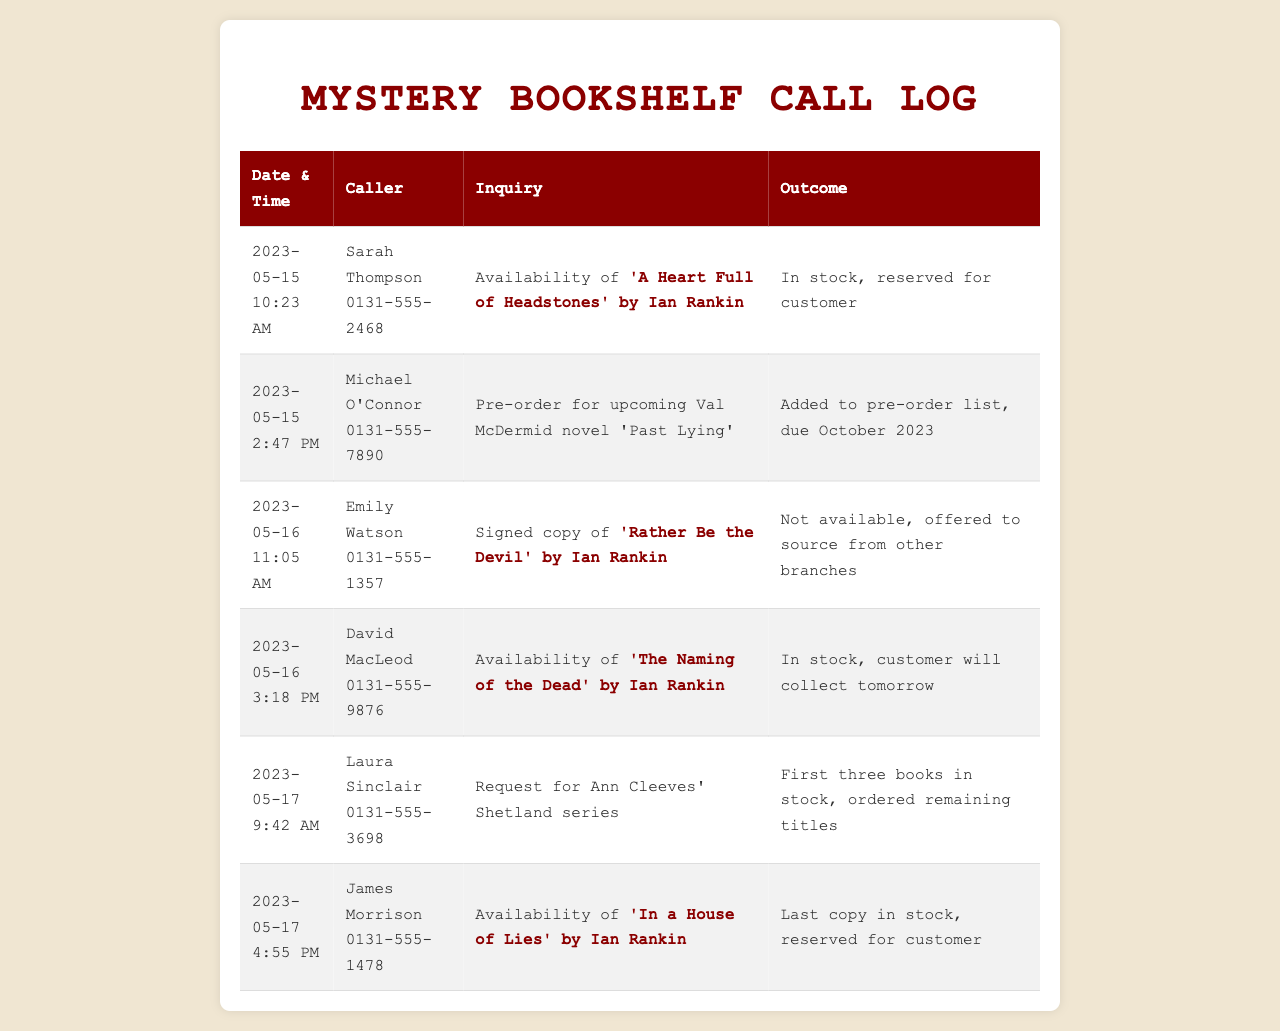what was the date and time of Sarah Thompson's call? Sarah Thompson's call occurred on May 15, 2023, at 10:23 AM.
Answer: May 15, 2023, 10:23 AM which Ian Rankin book was David MacLeod inquiring about? David MacLeod was inquiring about 'The Naming of the Dead' by Ian Rankin.
Answer: 'The Naming of the Dead' how many books of Ann Cleeves' Shetland series are in stock? The log mentions that the first three books in Ann Cleeves' Shetland series are in stock.
Answer: Three what was the outcome of Emily Watson's inquiry? Emily Watson inquired about a signed copy of 'Rather Be the Devil' by Ian Rankin, which was not available.
Answer: Not available who made a pre-order for a Val McDermid novel? Michael O'Connor made a pre-order for the upcoming Val McDermid novel 'Past Lying'.
Answer: Michael O'Connor how many calls were made in total as per the log? The log contains six entries of calls made by customers.
Answer: Six what was the outcome for James Morrison's inquiry? James Morrison's inquiry about 'In a House of Lies' by Ian Rankin resulted in the last copy being reserved for him.
Answer: Reserved for customer which customer requested information on a specific Ian Rankin title on May 17? James Morrison requested information on 'In a House of Lies' by Ian Rankin on May 17.
Answer: James Morrison 